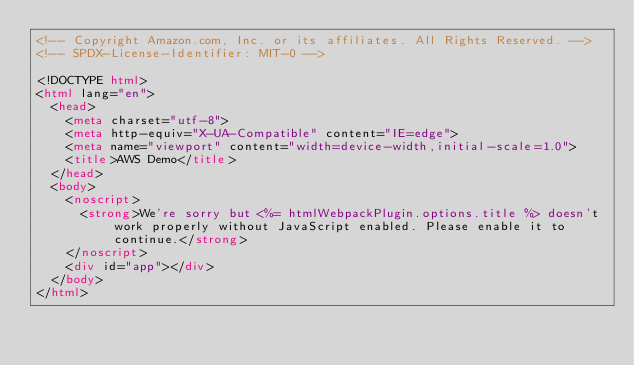<code> <loc_0><loc_0><loc_500><loc_500><_HTML_><!-- Copyright Amazon.com, Inc. or its affiliates. All Rights Reserved. -->
<!-- SPDX-License-Identifier: MIT-0 -->

<!DOCTYPE html>
<html lang="en">
  <head>
    <meta charset="utf-8">
    <meta http-equiv="X-UA-Compatible" content="IE=edge">
    <meta name="viewport" content="width=device-width,initial-scale=1.0">
    <title>AWS Demo</title>
  </head>
  <body>
    <noscript>
      <strong>We're sorry but <%= htmlWebpackPlugin.options.title %> doesn't work properly without JavaScript enabled. Please enable it to continue.</strong>
    </noscript>
    <div id="app"></div>
  </body>
</html>
</code> 